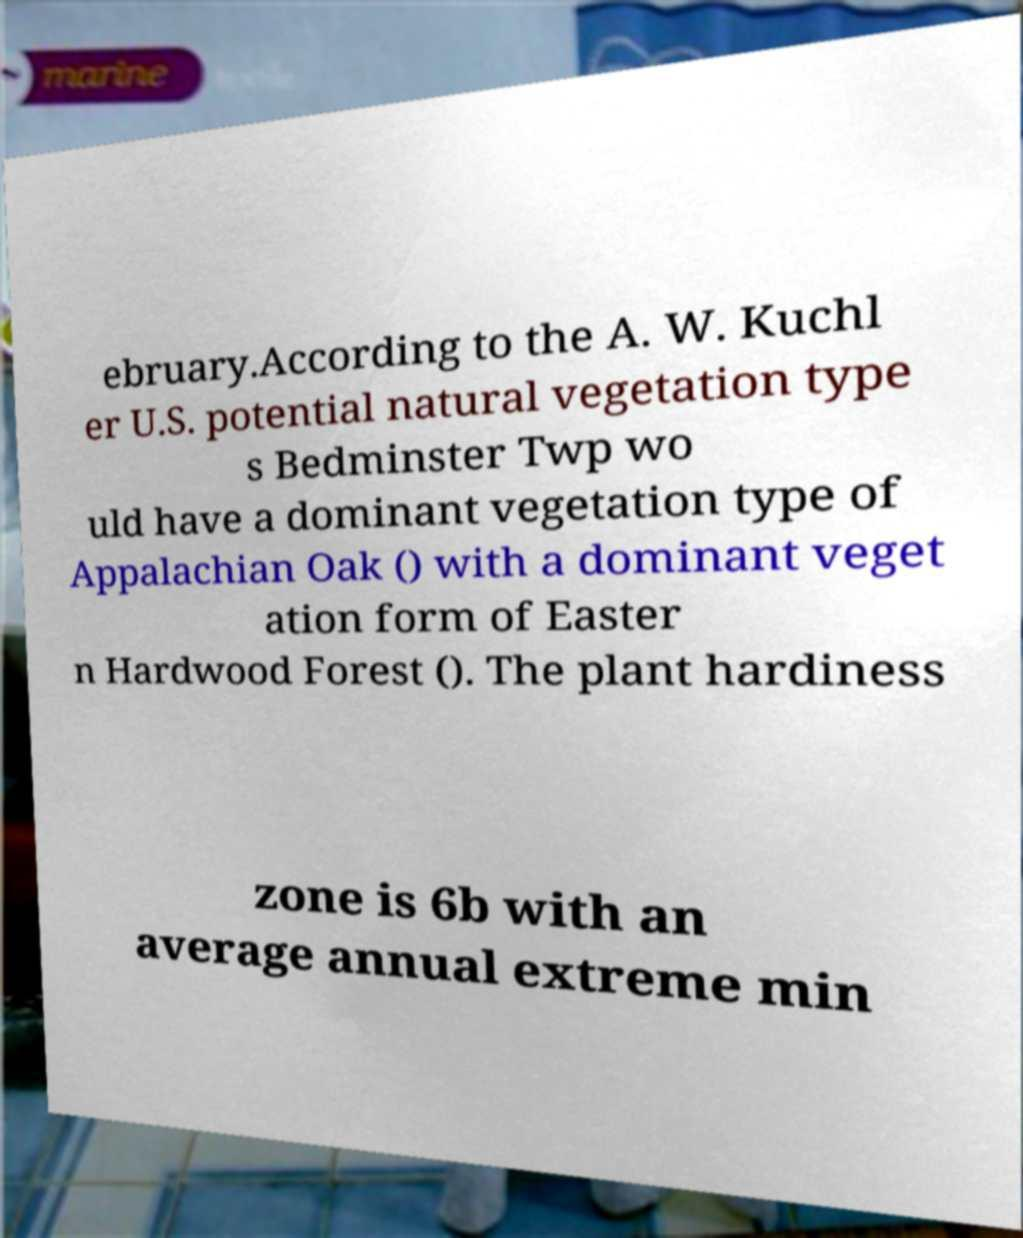I need the written content from this picture converted into text. Can you do that? ebruary.According to the A. W. Kuchl er U.S. potential natural vegetation type s Bedminster Twp wo uld have a dominant vegetation type of Appalachian Oak () with a dominant veget ation form of Easter n Hardwood Forest (). The plant hardiness zone is 6b with an average annual extreme min 